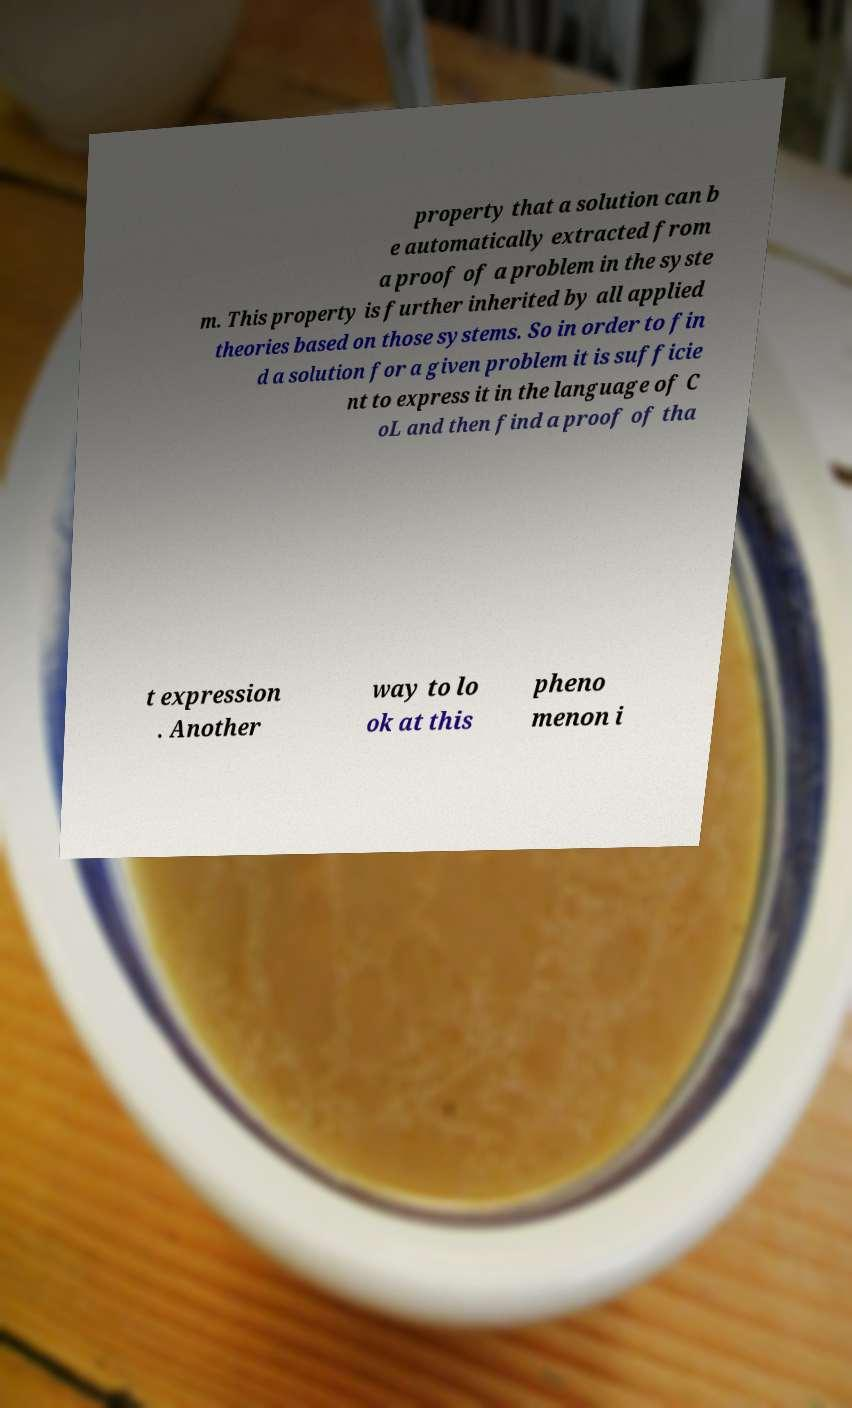Could you assist in decoding the text presented in this image and type it out clearly? property that a solution can b e automatically extracted from a proof of a problem in the syste m. This property is further inherited by all applied theories based on those systems. So in order to fin d a solution for a given problem it is sufficie nt to express it in the language of C oL and then find a proof of tha t expression . Another way to lo ok at this pheno menon i 